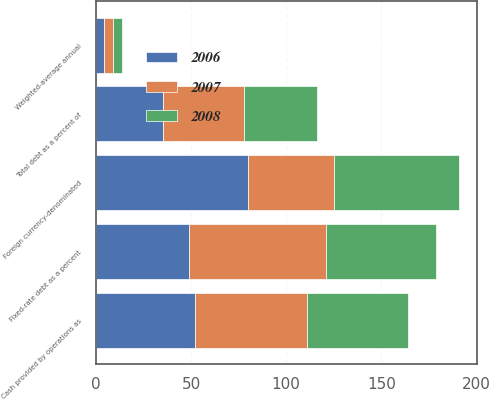Convert chart to OTSL. <chart><loc_0><loc_0><loc_500><loc_500><stacked_bar_chart><ecel><fcel>Fixed-rate debt as a percent<fcel>Weighted-average annual<fcel>Foreign currency-denominated<fcel>Total debt as a percent of<fcel>Cash provided by operations as<nl><fcel>2007<fcel>72<fcel>5<fcel>45<fcel>43<fcel>59<nl><fcel>2008<fcel>58<fcel>4.7<fcel>66<fcel>38<fcel>53<nl><fcel>2006<fcel>49<fcel>4.1<fcel>80<fcel>35<fcel>52<nl></chart> 